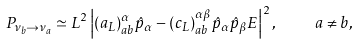Convert formula to latex. <formula><loc_0><loc_0><loc_500><loc_500>P _ { \nu _ { b } \to \nu _ { a } } \simeq L ^ { 2 } \left | ( a _ { L } ) ^ { \alpha } _ { a b } \hat { p } _ { \alpha } - ( c _ { L } ) ^ { \alpha \beta } _ { a b } \hat { p } _ { \alpha } \hat { p } _ { \beta } E \right | ^ { 2 } , \quad a \neq b ,</formula> 